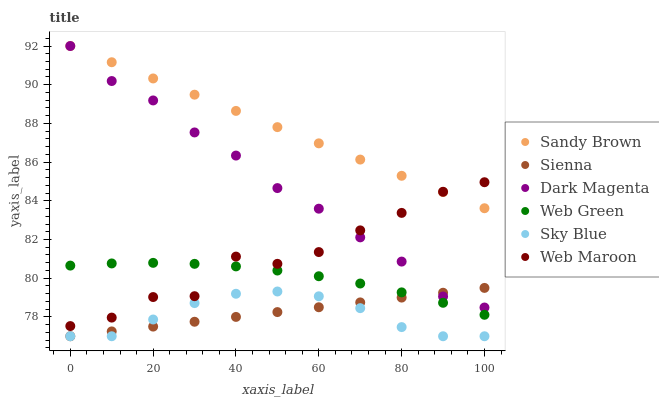Does Sky Blue have the minimum area under the curve?
Answer yes or no. Yes. Does Sandy Brown have the maximum area under the curve?
Answer yes or no. Yes. Does Web Maroon have the minimum area under the curve?
Answer yes or no. No. Does Web Maroon have the maximum area under the curve?
Answer yes or no. No. Is Sandy Brown the smoothest?
Answer yes or no. Yes. Is Web Maroon the roughest?
Answer yes or no. Yes. Is Web Green the smoothest?
Answer yes or no. No. Is Web Green the roughest?
Answer yes or no. No. Does Sienna have the lowest value?
Answer yes or no. Yes. Does Web Maroon have the lowest value?
Answer yes or no. No. Does Sandy Brown have the highest value?
Answer yes or no. Yes. Does Web Maroon have the highest value?
Answer yes or no. No. Is Sky Blue less than Web Maroon?
Answer yes or no. Yes. Is Web Maroon greater than Sky Blue?
Answer yes or no. Yes. Does Sienna intersect Sky Blue?
Answer yes or no. Yes. Is Sienna less than Sky Blue?
Answer yes or no. No. Is Sienna greater than Sky Blue?
Answer yes or no. No. Does Sky Blue intersect Web Maroon?
Answer yes or no. No. 